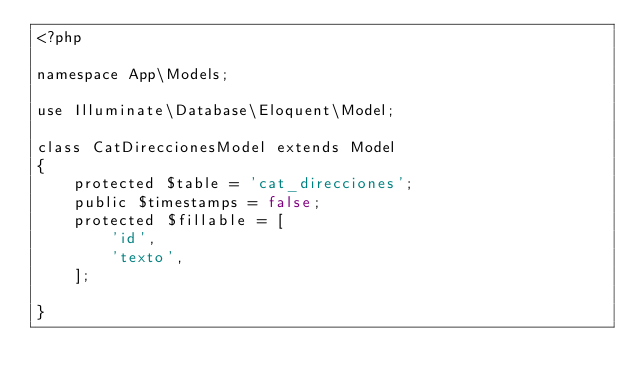Convert code to text. <code><loc_0><loc_0><loc_500><loc_500><_PHP_><?php

namespace App\Models;

use Illuminate\Database\Eloquent\Model;

class CatDireccionesModel extends Model
{
    protected $table = 'cat_direcciones';
    public $timestamps = false;
    protected $fillable = [
        'id',
        'texto',
    ];

}
</code> 